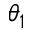Convert formula to latex. <formula><loc_0><loc_0><loc_500><loc_500>\theta _ { 1 }</formula> 